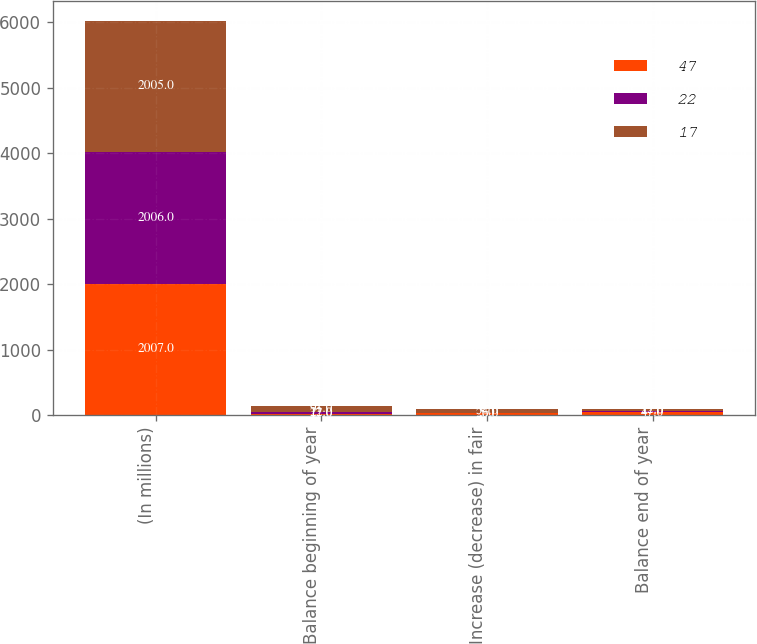Convert chart to OTSL. <chart><loc_0><loc_0><loc_500><loc_500><stacked_bar_chart><ecel><fcel>(In millions)<fcel>Balance beginning of year<fcel>Increase (decrease) in fair<fcel>Balance end of year<nl><fcel>47<fcel>2007<fcel>17<fcel>26<fcel>47<nl><fcel>22<fcel>2006<fcel>22<fcel>5<fcel>17<nl><fcel>17<fcel>2005<fcel>91<fcel>54<fcel>22<nl></chart> 